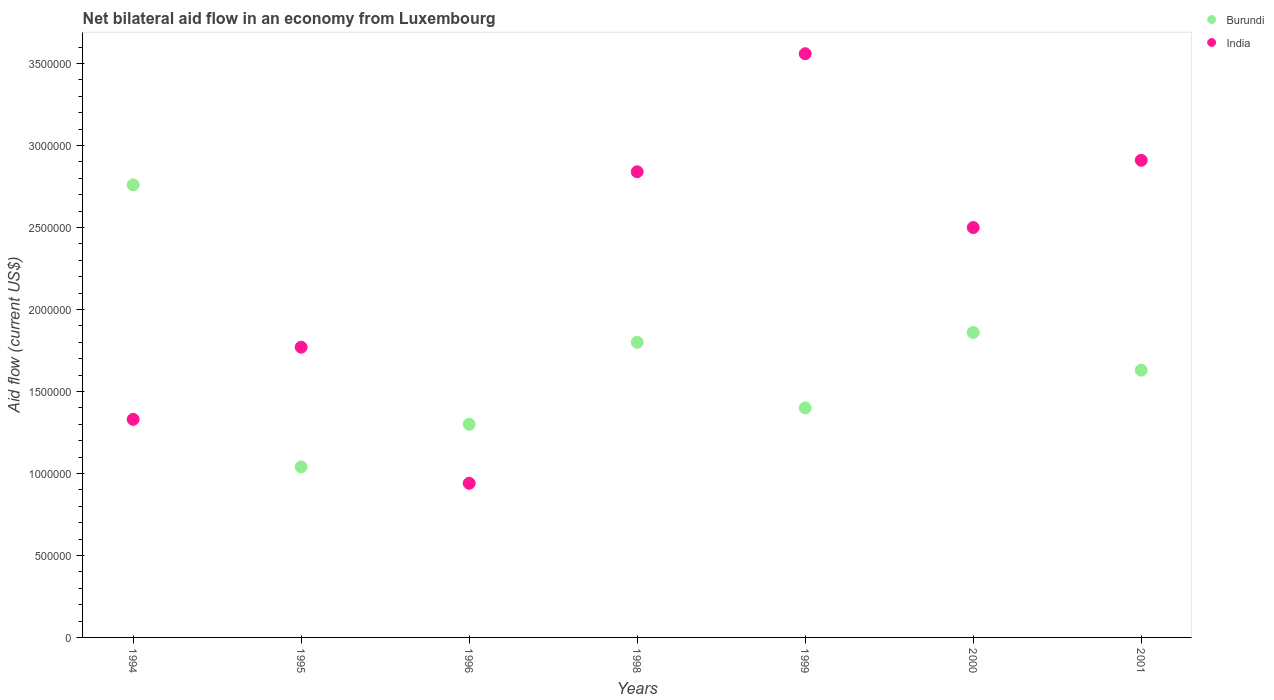What is the net bilateral aid flow in Burundi in 2001?
Provide a short and direct response. 1.63e+06. Across all years, what is the maximum net bilateral aid flow in India?
Your response must be concise. 3.56e+06. Across all years, what is the minimum net bilateral aid flow in Burundi?
Provide a succinct answer. 1.04e+06. In which year was the net bilateral aid flow in Burundi maximum?
Provide a succinct answer. 1994. What is the total net bilateral aid flow in India in the graph?
Ensure brevity in your answer.  1.58e+07. What is the difference between the net bilateral aid flow in India in 1998 and that in 2000?
Your response must be concise. 3.40e+05. What is the difference between the net bilateral aid flow in Burundi in 2000 and the net bilateral aid flow in India in 1996?
Keep it short and to the point. 9.20e+05. What is the average net bilateral aid flow in India per year?
Make the answer very short. 2.26e+06. In the year 1994, what is the difference between the net bilateral aid flow in Burundi and net bilateral aid flow in India?
Give a very brief answer. 1.43e+06. In how many years, is the net bilateral aid flow in Burundi greater than 2300000 US$?
Offer a very short reply. 1. What is the ratio of the net bilateral aid flow in India in 1999 to that in 2001?
Keep it short and to the point. 1.22. Is the net bilateral aid flow in India in 1995 less than that in 2000?
Offer a terse response. Yes. What is the difference between the highest and the second highest net bilateral aid flow in India?
Your answer should be compact. 6.50e+05. What is the difference between the highest and the lowest net bilateral aid flow in India?
Your answer should be compact. 2.62e+06. Is the sum of the net bilateral aid flow in India in 1996 and 1998 greater than the maximum net bilateral aid flow in Burundi across all years?
Make the answer very short. Yes. Does the net bilateral aid flow in India monotonically increase over the years?
Your answer should be very brief. No. Is the net bilateral aid flow in Burundi strictly greater than the net bilateral aid flow in India over the years?
Offer a very short reply. No. How many dotlines are there?
Offer a very short reply. 2. Are the values on the major ticks of Y-axis written in scientific E-notation?
Provide a succinct answer. No. Does the graph contain grids?
Provide a short and direct response. No. What is the title of the graph?
Provide a short and direct response. Net bilateral aid flow in an economy from Luxembourg. What is the Aid flow (current US$) in Burundi in 1994?
Offer a terse response. 2.76e+06. What is the Aid flow (current US$) in India in 1994?
Your answer should be compact. 1.33e+06. What is the Aid flow (current US$) of Burundi in 1995?
Ensure brevity in your answer.  1.04e+06. What is the Aid flow (current US$) in India in 1995?
Your answer should be very brief. 1.77e+06. What is the Aid flow (current US$) in Burundi in 1996?
Your answer should be compact. 1.30e+06. What is the Aid flow (current US$) in India in 1996?
Make the answer very short. 9.40e+05. What is the Aid flow (current US$) of Burundi in 1998?
Provide a short and direct response. 1.80e+06. What is the Aid flow (current US$) of India in 1998?
Your response must be concise. 2.84e+06. What is the Aid flow (current US$) of Burundi in 1999?
Ensure brevity in your answer.  1.40e+06. What is the Aid flow (current US$) of India in 1999?
Your answer should be compact. 3.56e+06. What is the Aid flow (current US$) of Burundi in 2000?
Provide a short and direct response. 1.86e+06. What is the Aid flow (current US$) in India in 2000?
Give a very brief answer. 2.50e+06. What is the Aid flow (current US$) of Burundi in 2001?
Keep it short and to the point. 1.63e+06. What is the Aid flow (current US$) of India in 2001?
Provide a succinct answer. 2.91e+06. Across all years, what is the maximum Aid flow (current US$) in Burundi?
Your response must be concise. 2.76e+06. Across all years, what is the maximum Aid flow (current US$) of India?
Offer a terse response. 3.56e+06. Across all years, what is the minimum Aid flow (current US$) of Burundi?
Make the answer very short. 1.04e+06. Across all years, what is the minimum Aid flow (current US$) in India?
Provide a succinct answer. 9.40e+05. What is the total Aid flow (current US$) of Burundi in the graph?
Ensure brevity in your answer.  1.18e+07. What is the total Aid flow (current US$) in India in the graph?
Your answer should be very brief. 1.58e+07. What is the difference between the Aid flow (current US$) in Burundi in 1994 and that in 1995?
Make the answer very short. 1.72e+06. What is the difference between the Aid flow (current US$) of India in 1994 and that in 1995?
Offer a terse response. -4.40e+05. What is the difference between the Aid flow (current US$) of Burundi in 1994 and that in 1996?
Give a very brief answer. 1.46e+06. What is the difference between the Aid flow (current US$) in Burundi in 1994 and that in 1998?
Your answer should be compact. 9.60e+05. What is the difference between the Aid flow (current US$) of India in 1994 and that in 1998?
Offer a terse response. -1.51e+06. What is the difference between the Aid flow (current US$) of Burundi in 1994 and that in 1999?
Your answer should be very brief. 1.36e+06. What is the difference between the Aid flow (current US$) of India in 1994 and that in 1999?
Your response must be concise. -2.23e+06. What is the difference between the Aid flow (current US$) in Burundi in 1994 and that in 2000?
Offer a very short reply. 9.00e+05. What is the difference between the Aid flow (current US$) in India in 1994 and that in 2000?
Your answer should be very brief. -1.17e+06. What is the difference between the Aid flow (current US$) in Burundi in 1994 and that in 2001?
Provide a short and direct response. 1.13e+06. What is the difference between the Aid flow (current US$) of India in 1994 and that in 2001?
Offer a very short reply. -1.58e+06. What is the difference between the Aid flow (current US$) of Burundi in 1995 and that in 1996?
Ensure brevity in your answer.  -2.60e+05. What is the difference between the Aid flow (current US$) in India in 1995 and that in 1996?
Your response must be concise. 8.30e+05. What is the difference between the Aid flow (current US$) of Burundi in 1995 and that in 1998?
Keep it short and to the point. -7.60e+05. What is the difference between the Aid flow (current US$) in India in 1995 and that in 1998?
Your answer should be very brief. -1.07e+06. What is the difference between the Aid flow (current US$) of Burundi in 1995 and that in 1999?
Offer a terse response. -3.60e+05. What is the difference between the Aid flow (current US$) of India in 1995 and that in 1999?
Provide a short and direct response. -1.79e+06. What is the difference between the Aid flow (current US$) of Burundi in 1995 and that in 2000?
Your response must be concise. -8.20e+05. What is the difference between the Aid flow (current US$) in India in 1995 and that in 2000?
Give a very brief answer. -7.30e+05. What is the difference between the Aid flow (current US$) of Burundi in 1995 and that in 2001?
Your answer should be very brief. -5.90e+05. What is the difference between the Aid flow (current US$) of India in 1995 and that in 2001?
Provide a succinct answer. -1.14e+06. What is the difference between the Aid flow (current US$) in Burundi in 1996 and that in 1998?
Make the answer very short. -5.00e+05. What is the difference between the Aid flow (current US$) in India in 1996 and that in 1998?
Provide a short and direct response. -1.90e+06. What is the difference between the Aid flow (current US$) in Burundi in 1996 and that in 1999?
Keep it short and to the point. -1.00e+05. What is the difference between the Aid flow (current US$) of India in 1996 and that in 1999?
Provide a short and direct response. -2.62e+06. What is the difference between the Aid flow (current US$) in Burundi in 1996 and that in 2000?
Your answer should be very brief. -5.60e+05. What is the difference between the Aid flow (current US$) in India in 1996 and that in 2000?
Your response must be concise. -1.56e+06. What is the difference between the Aid flow (current US$) in Burundi in 1996 and that in 2001?
Offer a very short reply. -3.30e+05. What is the difference between the Aid flow (current US$) in India in 1996 and that in 2001?
Your answer should be compact. -1.97e+06. What is the difference between the Aid flow (current US$) in Burundi in 1998 and that in 1999?
Your response must be concise. 4.00e+05. What is the difference between the Aid flow (current US$) of India in 1998 and that in 1999?
Your answer should be very brief. -7.20e+05. What is the difference between the Aid flow (current US$) in Burundi in 1998 and that in 2000?
Make the answer very short. -6.00e+04. What is the difference between the Aid flow (current US$) in Burundi in 1998 and that in 2001?
Offer a terse response. 1.70e+05. What is the difference between the Aid flow (current US$) of Burundi in 1999 and that in 2000?
Make the answer very short. -4.60e+05. What is the difference between the Aid flow (current US$) of India in 1999 and that in 2000?
Your response must be concise. 1.06e+06. What is the difference between the Aid flow (current US$) of India in 1999 and that in 2001?
Keep it short and to the point. 6.50e+05. What is the difference between the Aid flow (current US$) of India in 2000 and that in 2001?
Your answer should be very brief. -4.10e+05. What is the difference between the Aid flow (current US$) in Burundi in 1994 and the Aid flow (current US$) in India in 1995?
Your answer should be compact. 9.90e+05. What is the difference between the Aid flow (current US$) of Burundi in 1994 and the Aid flow (current US$) of India in 1996?
Ensure brevity in your answer.  1.82e+06. What is the difference between the Aid flow (current US$) in Burundi in 1994 and the Aid flow (current US$) in India in 1998?
Offer a very short reply. -8.00e+04. What is the difference between the Aid flow (current US$) of Burundi in 1994 and the Aid flow (current US$) of India in 1999?
Offer a terse response. -8.00e+05. What is the difference between the Aid flow (current US$) in Burundi in 1995 and the Aid flow (current US$) in India in 1998?
Your answer should be very brief. -1.80e+06. What is the difference between the Aid flow (current US$) in Burundi in 1995 and the Aid flow (current US$) in India in 1999?
Your response must be concise. -2.52e+06. What is the difference between the Aid flow (current US$) of Burundi in 1995 and the Aid flow (current US$) of India in 2000?
Keep it short and to the point. -1.46e+06. What is the difference between the Aid flow (current US$) of Burundi in 1995 and the Aid flow (current US$) of India in 2001?
Your response must be concise. -1.87e+06. What is the difference between the Aid flow (current US$) in Burundi in 1996 and the Aid flow (current US$) in India in 1998?
Provide a succinct answer. -1.54e+06. What is the difference between the Aid flow (current US$) of Burundi in 1996 and the Aid flow (current US$) of India in 1999?
Provide a short and direct response. -2.26e+06. What is the difference between the Aid flow (current US$) of Burundi in 1996 and the Aid flow (current US$) of India in 2000?
Offer a terse response. -1.20e+06. What is the difference between the Aid flow (current US$) in Burundi in 1996 and the Aid flow (current US$) in India in 2001?
Offer a very short reply. -1.61e+06. What is the difference between the Aid flow (current US$) of Burundi in 1998 and the Aid flow (current US$) of India in 1999?
Provide a succinct answer. -1.76e+06. What is the difference between the Aid flow (current US$) in Burundi in 1998 and the Aid flow (current US$) in India in 2000?
Give a very brief answer. -7.00e+05. What is the difference between the Aid flow (current US$) of Burundi in 1998 and the Aid flow (current US$) of India in 2001?
Ensure brevity in your answer.  -1.11e+06. What is the difference between the Aid flow (current US$) in Burundi in 1999 and the Aid flow (current US$) in India in 2000?
Give a very brief answer. -1.10e+06. What is the difference between the Aid flow (current US$) of Burundi in 1999 and the Aid flow (current US$) of India in 2001?
Keep it short and to the point. -1.51e+06. What is the difference between the Aid flow (current US$) in Burundi in 2000 and the Aid flow (current US$) in India in 2001?
Keep it short and to the point. -1.05e+06. What is the average Aid flow (current US$) of Burundi per year?
Offer a very short reply. 1.68e+06. What is the average Aid flow (current US$) in India per year?
Keep it short and to the point. 2.26e+06. In the year 1994, what is the difference between the Aid flow (current US$) in Burundi and Aid flow (current US$) in India?
Your answer should be compact. 1.43e+06. In the year 1995, what is the difference between the Aid flow (current US$) of Burundi and Aid flow (current US$) of India?
Provide a short and direct response. -7.30e+05. In the year 1998, what is the difference between the Aid flow (current US$) in Burundi and Aid flow (current US$) in India?
Offer a very short reply. -1.04e+06. In the year 1999, what is the difference between the Aid flow (current US$) in Burundi and Aid flow (current US$) in India?
Your response must be concise. -2.16e+06. In the year 2000, what is the difference between the Aid flow (current US$) in Burundi and Aid flow (current US$) in India?
Make the answer very short. -6.40e+05. In the year 2001, what is the difference between the Aid flow (current US$) of Burundi and Aid flow (current US$) of India?
Offer a very short reply. -1.28e+06. What is the ratio of the Aid flow (current US$) in Burundi in 1994 to that in 1995?
Your answer should be compact. 2.65. What is the ratio of the Aid flow (current US$) in India in 1994 to that in 1995?
Ensure brevity in your answer.  0.75. What is the ratio of the Aid flow (current US$) of Burundi in 1994 to that in 1996?
Ensure brevity in your answer.  2.12. What is the ratio of the Aid flow (current US$) of India in 1994 to that in 1996?
Provide a short and direct response. 1.41. What is the ratio of the Aid flow (current US$) of Burundi in 1994 to that in 1998?
Keep it short and to the point. 1.53. What is the ratio of the Aid flow (current US$) of India in 1994 to that in 1998?
Provide a succinct answer. 0.47. What is the ratio of the Aid flow (current US$) of Burundi in 1994 to that in 1999?
Make the answer very short. 1.97. What is the ratio of the Aid flow (current US$) of India in 1994 to that in 1999?
Make the answer very short. 0.37. What is the ratio of the Aid flow (current US$) of Burundi in 1994 to that in 2000?
Your answer should be very brief. 1.48. What is the ratio of the Aid flow (current US$) of India in 1994 to that in 2000?
Provide a succinct answer. 0.53. What is the ratio of the Aid flow (current US$) in Burundi in 1994 to that in 2001?
Ensure brevity in your answer.  1.69. What is the ratio of the Aid flow (current US$) of India in 1994 to that in 2001?
Keep it short and to the point. 0.46. What is the ratio of the Aid flow (current US$) in Burundi in 1995 to that in 1996?
Offer a terse response. 0.8. What is the ratio of the Aid flow (current US$) in India in 1995 to that in 1996?
Offer a terse response. 1.88. What is the ratio of the Aid flow (current US$) in Burundi in 1995 to that in 1998?
Provide a succinct answer. 0.58. What is the ratio of the Aid flow (current US$) of India in 1995 to that in 1998?
Offer a very short reply. 0.62. What is the ratio of the Aid flow (current US$) of Burundi in 1995 to that in 1999?
Your answer should be very brief. 0.74. What is the ratio of the Aid flow (current US$) of India in 1995 to that in 1999?
Offer a terse response. 0.5. What is the ratio of the Aid flow (current US$) in Burundi in 1995 to that in 2000?
Your answer should be very brief. 0.56. What is the ratio of the Aid flow (current US$) in India in 1995 to that in 2000?
Provide a succinct answer. 0.71. What is the ratio of the Aid flow (current US$) in Burundi in 1995 to that in 2001?
Ensure brevity in your answer.  0.64. What is the ratio of the Aid flow (current US$) of India in 1995 to that in 2001?
Provide a succinct answer. 0.61. What is the ratio of the Aid flow (current US$) in Burundi in 1996 to that in 1998?
Ensure brevity in your answer.  0.72. What is the ratio of the Aid flow (current US$) in India in 1996 to that in 1998?
Provide a short and direct response. 0.33. What is the ratio of the Aid flow (current US$) of Burundi in 1996 to that in 1999?
Provide a short and direct response. 0.93. What is the ratio of the Aid flow (current US$) of India in 1996 to that in 1999?
Provide a short and direct response. 0.26. What is the ratio of the Aid flow (current US$) in Burundi in 1996 to that in 2000?
Make the answer very short. 0.7. What is the ratio of the Aid flow (current US$) in India in 1996 to that in 2000?
Provide a short and direct response. 0.38. What is the ratio of the Aid flow (current US$) of Burundi in 1996 to that in 2001?
Your answer should be compact. 0.8. What is the ratio of the Aid flow (current US$) of India in 1996 to that in 2001?
Ensure brevity in your answer.  0.32. What is the ratio of the Aid flow (current US$) of India in 1998 to that in 1999?
Keep it short and to the point. 0.8. What is the ratio of the Aid flow (current US$) in Burundi in 1998 to that in 2000?
Make the answer very short. 0.97. What is the ratio of the Aid flow (current US$) in India in 1998 to that in 2000?
Give a very brief answer. 1.14. What is the ratio of the Aid flow (current US$) in Burundi in 1998 to that in 2001?
Your answer should be very brief. 1.1. What is the ratio of the Aid flow (current US$) in India in 1998 to that in 2001?
Provide a short and direct response. 0.98. What is the ratio of the Aid flow (current US$) of Burundi in 1999 to that in 2000?
Ensure brevity in your answer.  0.75. What is the ratio of the Aid flow (current US$) of India in 1999 to that in 2000?
Your response must be concise. 1.42. What is the ratio of the Aid flow (current US$) in Burundi in 1999 to that in 2001?
Provide a short and direct response. 0.86. What is the ratio of the Aid flow (current US$) of India in 1999 to that in 2001?
Offer a very short reply. 1.22. What is the ratio of the Aid flow (current US$) of Burundi in 2000 to that in 2001?
Give a very brief answer. 1.14. What is the ratio of the Aid flow (current US$) in India in 2000 to that in 2001?
Provide a short and direct response. 0.86. What is the difference between the highest and the second highest Aid flow (current US$) in India?
Offer a terse response. 6.50e+05. What is the difference between the highest and the lowest Aid flow (current US$) of Burundi?
Give a very brief answer. 1.72e+06. What is the difference between the highest and the lowest Aid flow (current US$) of India?
Your answer should be compact. 2.62e+06. 